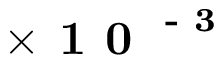<formula> <loc_0><loc_0><loc_500><loc_500>\times 1 0 ^ { - 3 }</formula> 